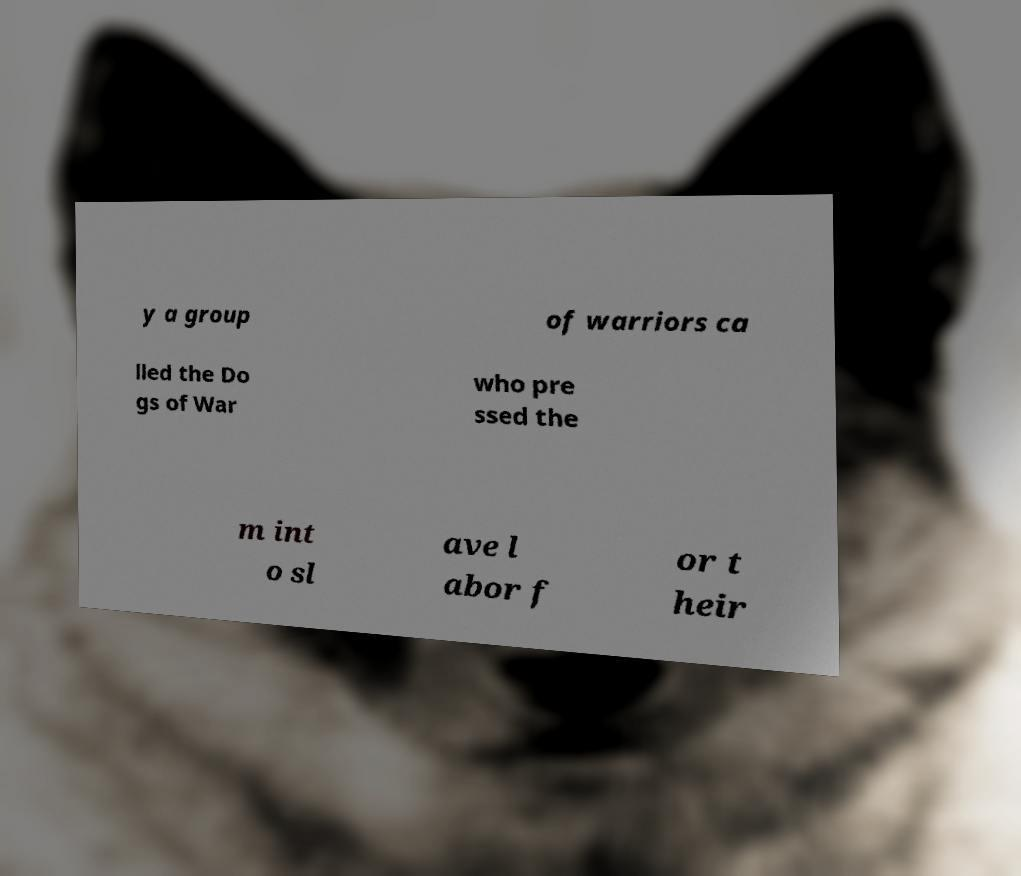For documentation purposes, I need the text within this image transcribed. Could you provide that? y a group of warriors ca lled the Do gs of War who pre ssed the m int o sl ave l abor f or t heir 